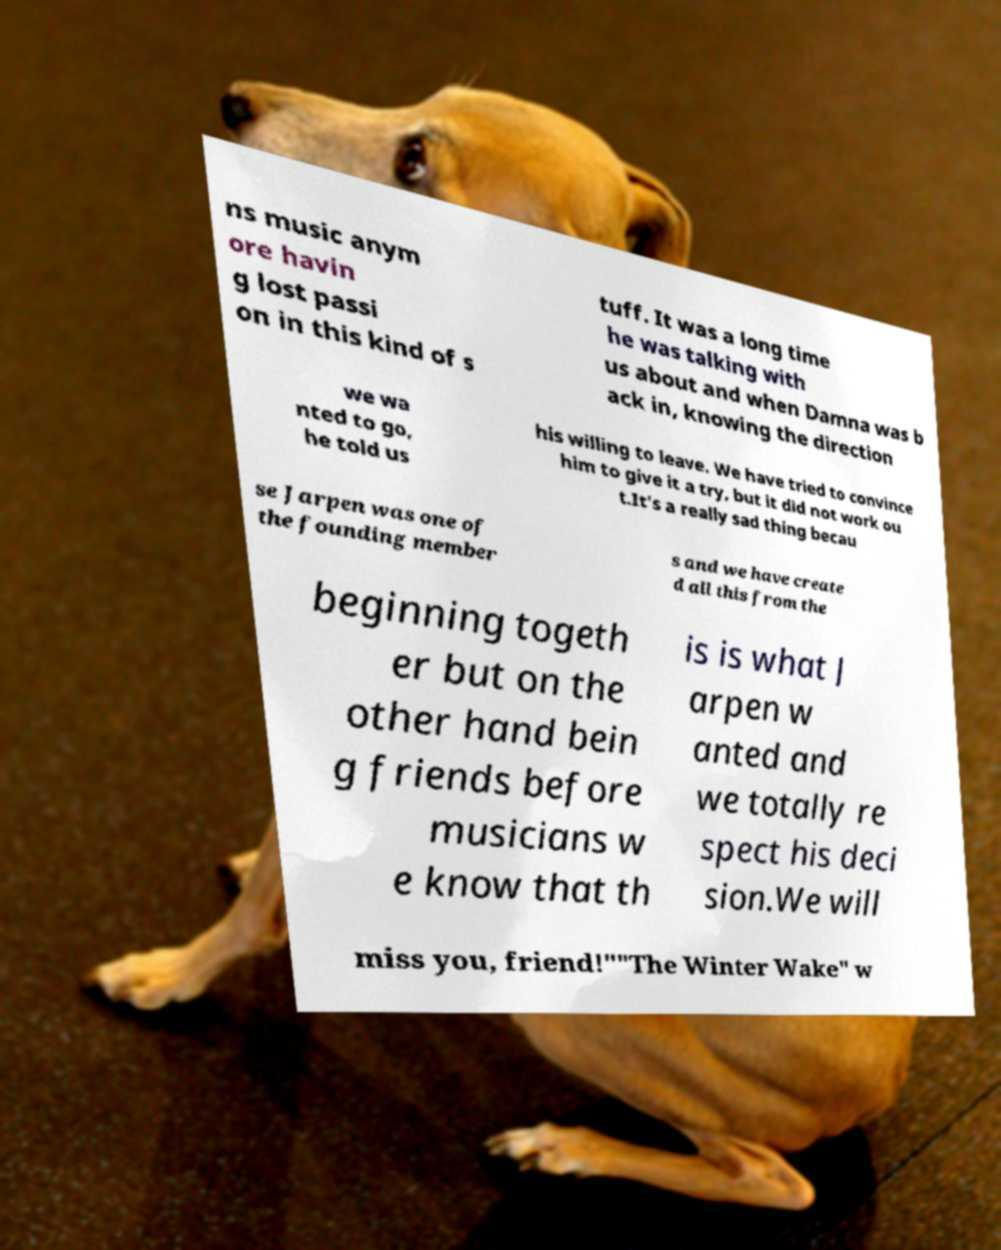What messages or text are displayed in this image? I need them in a readable, typed format. ns music anym ore havin g lost passi on in this kind of s tuff. It was a long time he was talking with us about and when Damna was b ack in, knowing the direction we wa nted to go, he told us his willing to leave. We have tried to convince him to give it a try, but it did not work ou t.It's a really sad thing becau se Jarpen was one of the founding member s and we have create d all this from the beginning togeth er but on the other hand bein g friends before musicians w e know that th is is what J arpen w anted and we totally re spect his deci sion.We will miss you, friend!""The Winter Wake" w 